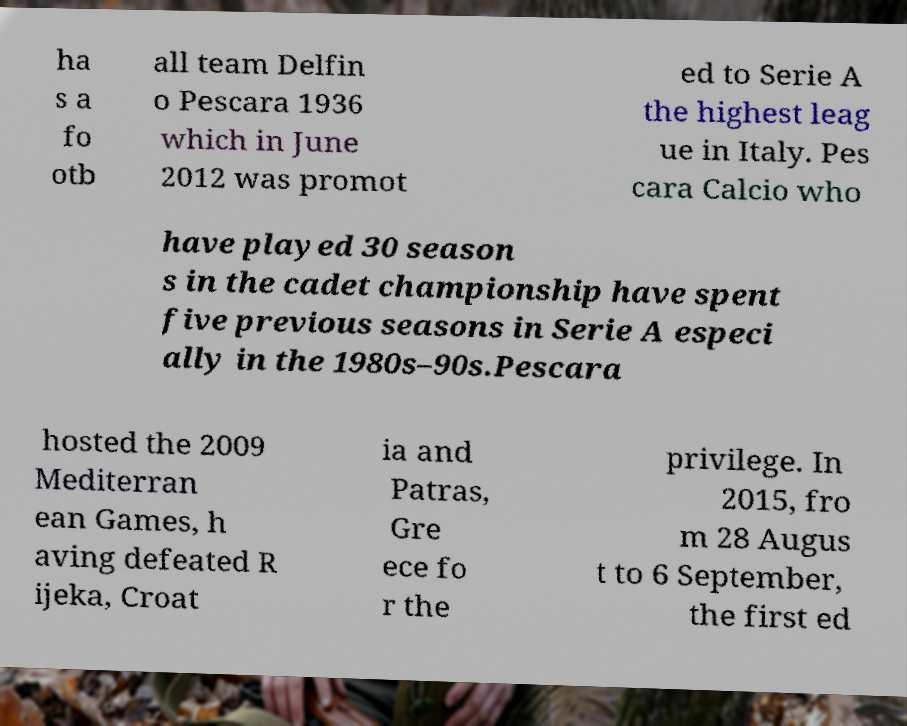Could you assist in decoding the text presented in this image and type it out clearly? ha s a fo otb all team Delfin o Pescara 1936 which in June 2012 was promot ed to Serie A the highest leag ue in Italy. Pes cara Calcio who have played 30 season s in the cadet championship have spent five previous seasons in Serie A especi ally in the 1980s–90s.Pescara hosted the 2009 Mediterran ean Games, h aving defeated R ijeka, Croat ia and Patras, Gre ece fo r the privilege. In 2015, fro m 28 Augus t to 6 September, the first ed 